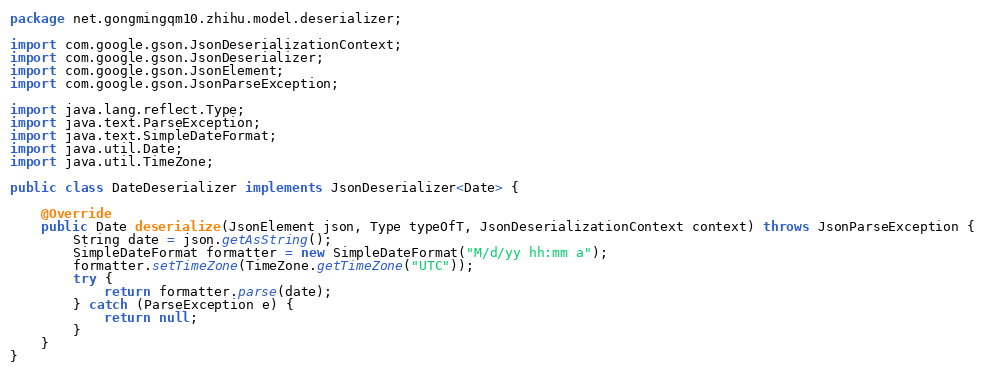<code> <loc_0><loc_0><loc_500><loc_500><_Java_>package net.gongmingqm10.zhihu.model.deserializer;

import com.google.gson.JsonDeserializationContext;
import com.google.gson.JsonDeserializer;
import com.google.gson.JsonElement;
import com.google.gson.JsonParseException;

import java.lang.reflect.Type;
import java.text.ParseException;
import java.text.SimpleDateFormat;
import java.util.Date;
import java.util.TimeZone;

public class DateDeserializer implements JsonDeserializer<Date> {

    @Override
    public Date deserialize(JsonElement json, Type typeOfT, JsonDeserializationContext context) throws JsonParseException {
        String date = json.getAsString();
        SimpleDateFormat formatter = new SimpleDateFormat("M/d/yy hh:mm a");
        formatter.setTimeZone(TimeZone.getTimeZone("UTC"));
        try {
            return formatter.parse(date);
        } catch (ParseException e) {
            return null;
        }
    }
}
</code> 